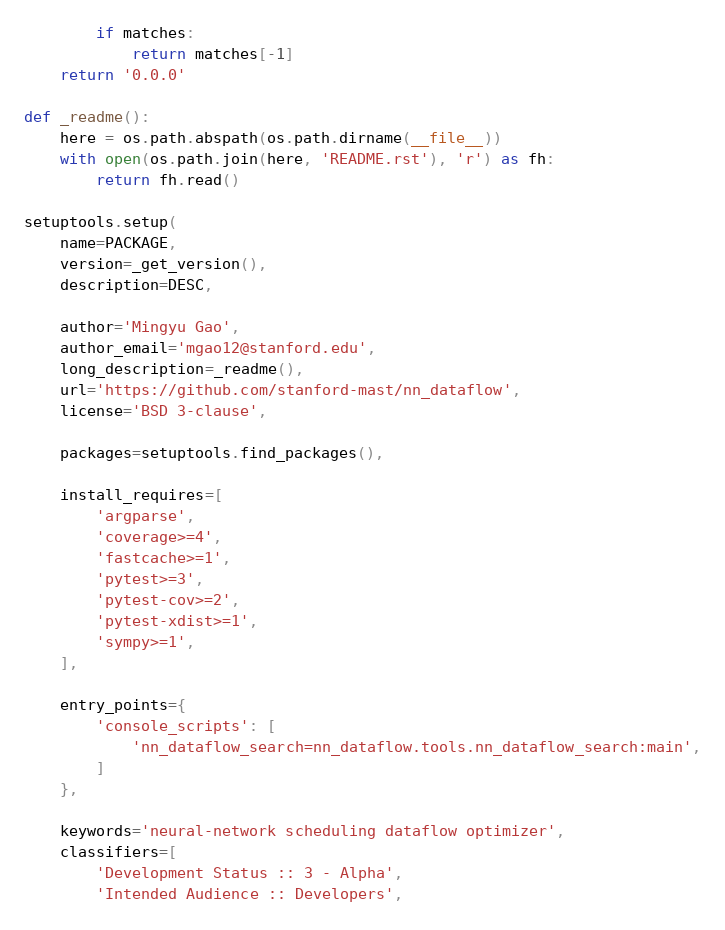<code> <loc_0><loc_0><loc_500><loc_500><_Python_>        if matches:
            return matches[-1]
    return '0.0.0'

def _readme():
    here = os.path.abspath(os.path.dirname(__file__))
    with open(os.path.join(here, 'README.rst'), 'r') as fh:
        return fh.read()

setuptools.setup(
    name=PACKAGE,
    version=_get_version(),
    description=DESC,

    author='Mingyu Gao',
    author_email='mgao12@stanford.edu',
    long_description=_readme(),
    url='https://github.com/stanford-mast/nn_dataflow',
    license='BSD 3-clause',

    packages=setuptools.find_packages(),

    install_requires=[
        'argparse',
        'coverage>=4',
        'fastcache>=1',
        'pytest>=3',
        'pytest-cov>=2',
        'pytest-xdist>=1',
        'sympy>=1',
    ],

    entry_points={
        'console_scripts': [
            'nn_dataflow_search=nn_dataflow.tools.nn_dataflow_search:main',
        ]
    },

    keywords='neural-network scheduling dataflow optimizer',
    classifiers=[
        'Development Status :: 3 - Alpha',
        'Intended Audience :: Developers',</code> 